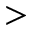Convert formula to latex. <formula><loc_0><loc_0><loc_500><loc_500>></formula> 